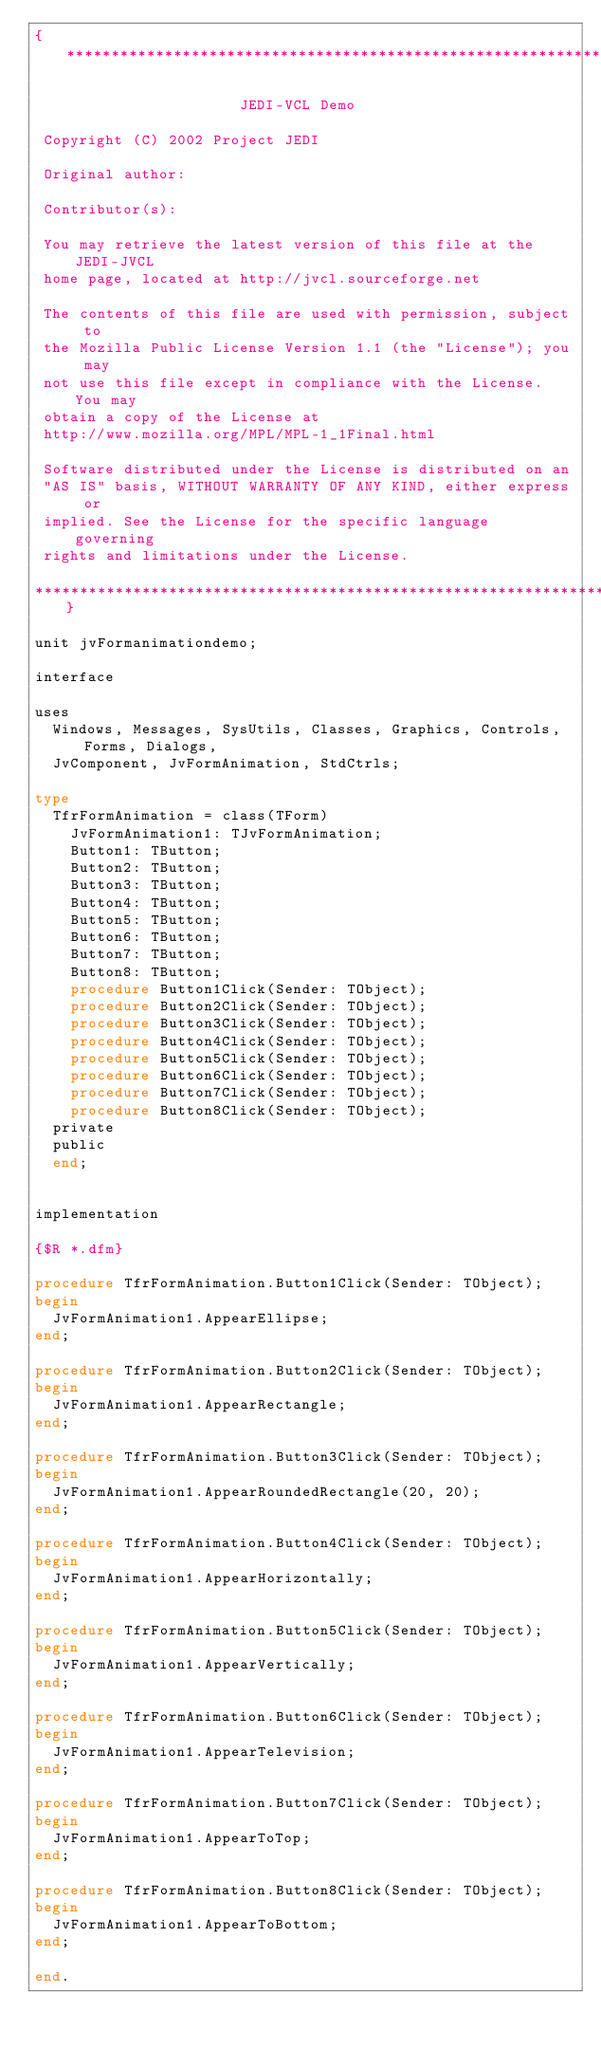<code> <loc_0><loc_0><loc_500><loc_500><_Pascal_>{******************************************************************

                       JEDI-VCL Demo

 Copyright (C) 2002 Project JEDI

 Original author:

 Contributor(s):

 You may retrieve the latest version of this file at the JEDI-JVCL
 home page, located at http://jvcl.sourceforge.net

 The contents of this file are used with permission, subject to
 the Mozilla Public License Version 1.1 (the "License"); you may
 not use this file except in compliance with the License. You may
 obtain a copy of the License at
 http://www.mozilla.org/MPL/MPL-1_1Final.html

 Software distributed under the License is distributed on an
 "AS IS" basis, WITHOUT WARRANTY OF ANY KIND, either express or
 implied. See the License for the specific language governing
 rights and limitations under the License.

******************************************************************}

unit jvFormanimationdemo;

interface

uses
  Windows, Messages, SysUtils, Classes, Graphics, Controls, Forms, Dialogs,
  JvComponent, JvFormAnimation, StdCtrls;

type
  TfrFormAnimation = class(TForm)
    JvFormAnimation1: TJvFormAnimation;
    Button1: TButton;
    Button2: TButton;
    Button3: TButton;
    Button4: TButton;
    Button5: TButton;
    Button6: TButton;
    Button7: TButton;
    Button8: TButton;
    procedure Button1Click(Sender: TObject);
    procedure Button2Click(Sender: TObject);
    procedure Button3Click(Sender: TObject);
    procedure Button4Click(Sender: TObject);
    procedure Button5Click(Sender: TObject);
    procedure Button6Click(Sender: TObject);
    procedure Button7Click(Sender: TObject);
    procedure Button8Click(Sender: TObject);
  private
  public
  end;


implementation

{$R *.dfm}

procedure TfrFormAnimation.Button1Click(Sender: TObject);
begin
  JvFormAnimation1.AppearEllipse;
end;

procedure TfrFormAnimation.Button2Click(Sender: TObject);
begin
  JvFormAnimation1.AppearRectangle;
end;

procedure TfrFormAnimation.Button3Click(Sender: TObject);
begin
  JvFormAnimation1.AppearRoundedRectangle(20, 20);
end;

procedure TfrFormAnimation.Button4Click(Sender: TObject);
begin
  JvFormAnimation1.AppearHorizontally;
end;

procedure TfrFormAnimation.Button5Click(Sender: TObject);
begin
  JvFormAnimation1.AppearVertically;
end;

procedure TfrFormAnimation.Button6Click(Sender: TObject);
begin
  JvFormAnimation1.AppearTelevision;
end;

procedure TfrFormAnimation.Button7Click(Sender: TObject);
begin
  JvFormAnimation1.AppearToTop;
end;

procedure TfrFormAnimation.Button8Click(Sender: TObject);
begin
  JvFormAnimation1.AppearToBottom;
end;

end.

</code> 